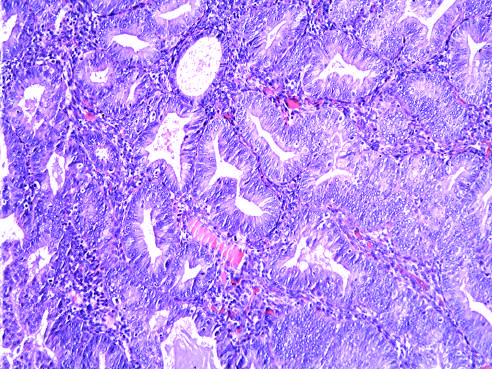what is hyperplasia with atypia seen as?
Answer the question using a single word or phrase. Glandular crowding and cellular atypia 